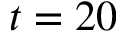<formula> <loc_0><loc_0><loc_500><loc_500>t = 2 0</formula> 